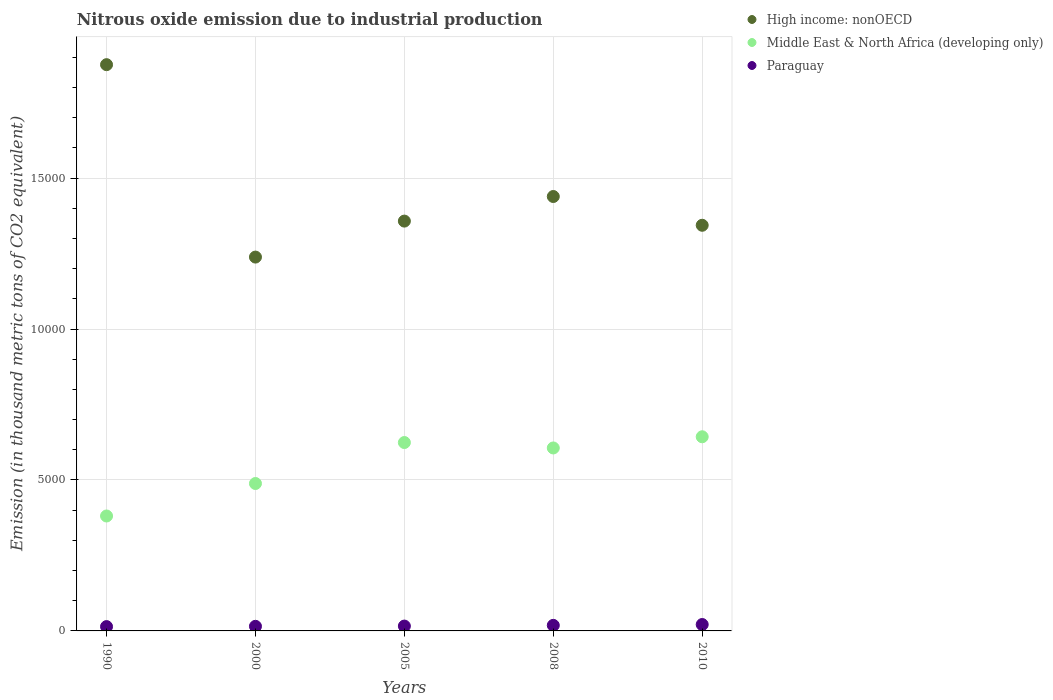How many different coloured dotlines are there?
Your response must be concise. 3. What is the amount of nitrous oxide emitted in Paraguay in 1990?
Your response must be concise. 143. Across all years, what is the maximum amount of nitrous oxide emitted in Paraguay?
Your response must be concise. 211.9. Across all years, what is the minimum amount of nitrous oxide emitted in High income: nonOECD?
Offer a terse response. 1.24e+04. In which year was the amount of nitrous oxide emitted in Middle East & North Africa (developing only) minimum?
Your response must be concise. 1990. What is the total amount of nitrous oxide emitted in High income: nonOECD in the graph?
Your answer should be compact. 7.25e+04. What is the difference between the amount of nitrous oxide emitted in Middle East & North Africa (developing only) in 1990 and that in 2005?
Provide a succinct answer. -2433. What is the difference between the amount of nitrous oxide emitted in High income: nonOECD in 2005 and the amount of nitrous oxide emitted in Middle East & North Africa (developing only) in 2010?
Your answer should be very brief. 7143.7. What is the average amount of nitrous oxide emitted in Paraguay per year?
Make the answer very short. 170.42. In the year 2008, what is the difference between the amount of nitrous oxide emitted in Middle East & North Africa (developing only) and amount of nitrous oxide emitted in Paraguay?
Provide a short and direct response. 5876.1. In how many years, is the amount of nitrous oxide emitted in Middle East & North Africa (developing only) greater than 9000 thousand metric tons?
Your answer should be compact. 0. What is the ratio of the amount of nitrous oxide emitted in High income: nonOECD in 1990 to that in 2008?
Make the answer very short. 1.3. What is the difference between the highest and the second highest amount of nitrous oxide emitted in High income: nonOECD?
Provide a short and direct response. 4366.8. What is the difference between the highest and the lowest amount of nitrous oxide emitted in Paraguay?
Offer a terse response. 68.9. Is it the case that in every year, the sum of the amount of nitrous oxide emitted in Middle East & North Africa (developing only) and amount of nitrous oxide emitted in Paraguay  is greater than the amount of nitrous oxide emitted in High income: nonOECD?
Provide a succinct answer. No. Does the amount of nitrous oxide emitted in Paraguay monotonically increase over the years?
Your answer should be compact. Yes. How many dotlines are there?
Make the answer very short. 3. How many years are there in the graph?
Your answer should be very brief. 5. What is the difference between two consecutive major ticks on the Y-axis?
Provide a short and direct response. 5000. Are the values on the major ticks of Y-axis written in scientific E-notation?
Your response must be concise. No. Does the graph contain grids?
Offer a very short reply. Yes. Where does the legend appear in the graph?
Provide a short and direct response. Top right. What is the title of the graph?
Provide a succinct answer. Nitrous oxide emission due to industrial production. Does "Panama" appear as one of the legend labels in the graph?
Ensure brevity in your answer.  No. What is the label or title of the X-axis?
Your answer should be very brief. Years. What is the label or title of the Y-axis?
Keep it short and to the point. Emission (in thousand metric tons of CO2 equivalent). What is the Emission (in thousand metric tons of CO2 equivalent) of High income: nonOECD in 1990?
Provide a succinct answer. 1.88e+04. What is the Emission (in thousand metric tons of CO2 equivalent) of Middle East & North Africa (developing only) in 1990?
Provide a short and direct response. 3806.6. What is the Emission (in thousand metric tons of CO2 equivalent) of Paraguay in 1990?
Keep it short and to the point. 143. What is the Emission (in thousand metric tons of CO2 equivalent) of High income: nonOECD in 2000?
Provide a succinct answer. 1.24e+04. What is the Emission (in thousand metric tons of CO2 equivalent) in Middle East & North Africa (developing only) in 2000?
Offer a very short reply. 4882.9. What is the Emission (in thousand metric tons of CO2 equivalent) in Paraguay in 2000?
Offer a very short reply. 152.5. What is the Emission (in thousand metric tons of CO2 equivalent) of High income: nonOECD in 2005?
Make the answer very short. 1.36e+04. What is the Emission (in thousand metric tons of CO2 equivalent) in Middle East & North Africa (developing only) in 2005?
Give a very brief answer. 6239.6. What is the Emission (in thousand metric tons of CO2 equivalent) in Paraguay in 2005?
Provide a succinct answer. 160.6. What is the Emission (in thousand metric tons of CO2 equivalent) in High income: nonOECD in 2008?
Provide a short and direct response. 1.44e+04. What is the Emission (in thousand metric tons of CO2 equivalent) in Middle East & North Africa (developing only) in 2008?
Your answer should be very brief. 6060.2. What is the Emission (in thousand metric tons of CO2 equivalent) in Paraguay in 2008?
Your response must be concise. 184.1. What is the Emission (in thousand metric tons of CO2 equivalent) of High income: nonOECD in 2010?
Ensure brevity in your answer.  1.34e+04. What is the Emission (in thousand metric tons of CO2 equivalent) in Middle East & North Africa (developing only) in 2010?
Provide a short and direct response. 6430.5. What is the Emission (in thousand metric tons of CO2 equivalent) of Paraguay in 2010?
Provide a short and direct response. 211.9. Across all years, what is the maximum Emission (in thousand metric tons of CO2 equivalent) of High income: nonOECD?
Your answer should be compact. 1.88e+04. Across all years, what is the maximum Emission (in thousand metric tons of CO2 equivalent) in Middle East & North Africa (developing only)?
Offer a terse response. 6430.5. Across all years, what is the maximum Emission (in thousand metric tons of CO2 equivalent) in Paraguay?
Ensure brevity in your answer.  211.9. Across all years, what is the minimum Emission (in thousand metric tons of CO2 equivalent) of High income: nonOECD?
Your answer should be very brief. 1.24e+04. Across all years, what is the minimum Emission (in thousand metric tons of CO2 equivalent) of Middle East & North Africa (developing only)?
Your answer should be very brief. 3806.6. Across all years, what is the minimum Emission (in thousand metric tons of CO2 equivalent) in Paraguay?
Your response must be concise. 143. What is the total Emission (in thousand metric tons of CO2 equivalent) of High income: nonOECD in the graph?
Ensure brevity in your answer.  7.25e+04. What is the total Emission (in thousand metric tons of CO2 equivalent) in Middle East & North Africa (developing only) in the graph?
Give a very brief answer. 2.74e+04. What is the total Emission (in thousand metric tons of CO2 equivalent) of Paraguay in the graph?
Your answer should be very brief. 852.1. What is the difference between the Emission (in thousand metric tons of CO2 equivalent) of High income: nonOECD in 1990 and that in 2000?
Provide a short and direct response. 6373.1. What is the difference between the Emission (in thousand metric tons of CO2 equivalent) in Middle East & North Africa (developing only) in 1990 and that in 2000?
Keep it short and to the point. -1076.3. What is the difference between the Emission (in thousand metric tons of CO2 equivalent) of Paraguay in 1990 and that in 2000?
Provide a short and direct response. -9.5. What is the difference between the Emission (in thousand metric tons of CO2 equivalent) in High income: nonOECD in 1990 and that in 2005?
Ensure brevity in your answer.  5181.3. What is the difference between the Emission (in thousand metric tons of CO2 equivalent) in Middle East & North Africa (developing only) in 1990 and that in 2005?
Your answer should be compact. -2433. What is the difference between the Emission (in thousand metric tons of CO2 equivalent) of Paraguay in 1990 and that in 2005?
Offer a terse response. -17.6. What is the difference between the Emission (in thousand metric tons of CO2 equivalent) in High income: nonOECD in 1990 and that in 2008?
Offer a very short reply. 4366.8. What is the difference between the Emission (in thousand metric tons of CO2 equivalent) of Middle East & North Africa (developing only) in 1990 and that in 2008?
Your answer should be very brief. -2253.6. What is the difference between the Emission (in thousand metric tons of CO2 equivalent) of Paraguay in 1990 and that in 2008?
Your answer should be very brief. -41.1. What is the difference between the Emission (in thousand metric tons of CO2 equivalent) in High income: nonOECD in 1990 and that in 2010?
Make the answer very short. 5319.5. What is the difference between the Emission (in thousand metric tons of CO2 equivalent) in Middle East & North Africa (developing only) in 1990 and that in 2010?
Keep it short and to the point. -2623.9. What is the difference between the Emission (in thousand metric tons of CO2 equivalent) of Paraguay in 1990 and that in 2010?
Make the answer very short. -68.9. What is the difference between the Emission (in thousand metric tons of CO2 equivalent) in High income: nonOECD in 2000 and that in 2005?
Your answer should be compact. -1191.8. What is the difference between the Emission (in thousand metric tons of CO2 equivalent) in Middle East & North Africa (developing only) in 2000 and that in 2005?
Give a very brief answer. -1356.7. What is the difference between the Emission (in thousand metric tons of CO2 equivalent) in High income: nonOECD in 2000 and that in 2008?
Ensure brevity in your answer.  -2006.3. What is the difference between the Emission (in thousand metric tons of CO2 equivalent) in Middle East & North Africa (developing only) in 2000 and that in 2008?
Offer a terse response. -1177.3. What is the difference between the Emission (in thousand metric tons of CO2 equivalent) of Paraguay in 2000 and that in 2008?
Provide a succinct answer. -31.6. What is the difference between the Emission (in thousand metric tons of CO2 equivalent) in High income: nonOECD in 2000 and that in 2010?
Give a very brief answer. -1053.6. What is the difference between the Emission (in thousand metric tons of CO2 equivalent) in Middle East & North Africa (developing only) in 2000 and that in 2010?
Ensure brevity in your answer.  -1547.6. What is the difference between the Emission (in thousand metric tons of CO2 equivalent) of Paraguay in 2000 and that in 2010?
Offer a very short reply. -59.4. What is the difference between the Emission (in thousand metric tons of CO2 equivalent) of High income: nonOECD in 2005 and that in 2008?
Your answer should be compact. -814.5. What is the difference between the Emission (in thousand metric tons of CO2 equivalent) of Middle East & North Africa (developing only) in 2005 and that in 2008?
Give a very brief answer. 179.4. What is the difference between the Emission (in thousand metric tons of CO2 equivalent) of Paraguay in 2005 and that in 2008?
Offer a very short reply. -23.5. What is the difference between the Emission (in thousand metric tons of CO2 equivalent) in High income: nonOECD in 2005 and that in 2010?
Your response must be concise. 138.2. What is the difference between the Emission (in thousand metric tons of CO2 equivalent) of Middle East & North Africa (developing only) in 2005 and that in 2010?
Offer a very short reply. -190.9. What is the difference between the Emission (in thousand metric tons of CO2 equivalent) of Paraguay in 2005 and that in 2010?
Make the answer very short. -51.3. What is the difference between the Emission (in thousand metric tons of CO2 equivalent) of High income: nonOECD in 2008 and that in 2010?
Your answer should be compact. 952.7. What is the difference between the Emission (in thousand metric tons of CO2 equivalent) of Middle East & North Africa (developing only) in 2008 and that in 2010?
Make the answer very short. -370.3. What is the difference between the Emission (in thousand metric tons of CO2 equivalent) in Paraguay in 2008 and that in 2010?
Make the answer very short. -27.8. What is the difference between the Emission (in thousand metric tons of CO2 equivalent) in High income: nonOECD in 1990 and the Emission (in thousand metric tons of CO2 equivalent) in Middle East & North Africa (developing only) in 2000?
Ensure brevity in your answer.  1.39e+04. What is the difference between the Emission (in thousand metric tons of CO2 equivalent) of High income: nonOECD in 1990 and the Emission (in thousand metric tons of CO2 equivalent) of Paraguay in 2000?
Ensure brevity in your answer.  1.86e+04. What is the difference between the Emission (in thousand metric tons of CO2 equivalent) of Middle East & North Africa (developing only) in 1990 and the Emission (in thousand metric tons of CO2 equivalent) of Paraguay in 2000?
Keep it short and to the point. 3654.1. What is the difference between the Emission (in thousand metric tons of CO2 equivalent) in High income: nonOECD in 1990 and the Emission (in thousand metric tons of CO2 equivalent) in Middle East & North Africa (developing only) in 2005?
Your response must be concise. 1.25e+04. What is the difference between the Emission (in thousand metric tons of CO2 equivalent) in High income: nonOECD in 1990 and the Emission (in thousand metric tons of CO2 equivalent) in Paraguay in 2005?
Keep it short and to the point. 1.86e+04. What is the difference between the Emission (in thousand metric tons of CO2 equivalent) in Middle East & North Africa (developing only) in 1990 and the Emission (in thousand metric tons of CO2 equivalent) in Paraguay in 2005?
Keep it short and to the point. 3646. What is the difference between the Emission (in thousand metric tons of CO2 equivalent) in High income: nonOECD in 1990 and the Emission (in thousand metric tons of CO2 equivalent) in Middle East & North Africa (developing only) in 2008?
Offer a terse response. 1.27e+04. What is the difference between the Emission (in thousand metric tons of CO2 equivalent) in High income: nonOECD in 1990 and the Emission (in thousand metric tons of CO2 equivalent) in Paraguay in 2008?
Give a very brief answer. 1.86e+04. What is the difference between the Emission (in thousand metric tons of CO2 equivalent) of Middle East & North Africa (developing only) in 1990 and the Emission (in thousand metric tons of CO2 equivalent) of Paraguay in 2008?
Your answer should be compact. 3622.5. What is the difference between the Emission (in thousand metric tons of CO2 equivalent) in High income: nonOECD in 1990 and the Emission (in thousand metric tons of CO2 equivalent) in Middle East & North Africa (developing only) in 2010?
Your response must be concise. 1.23e+04. What is the difference between the Emission (in thousand metric tons of CO2 equivalent) in High income: nonOECD in 1990 and the Emission (in thousand metric tons of CO2 equivalent) in Paraguay in 2010?
Keep it short and to the point. 1.85e+04. What is the difference between the Emission (in thousand metric tons of CO2 equivalent) of Middle East & North Africa (developing only) in 1990 and the Emission (in thousand metric tons of CO2 equivalent) of Paraguay in 2010?
Ensure brevity in your answer.  3594.7. What is the difference between the Emission (in thousand metric tons of CO2 equivalent) in High income: nonOECD in 2000 and the Emission (in thousand metric tons of CO2 equivalent) in Middle East & North Africa (developing only) in 2005?
Provide a short and direct response. 6142.8. What is the difference between the Emission (in thousand metric tons of CO2 equivalent) of High income: nonOECD in 2000 and the Emission (in thousand metric tons of CO2 equivalent) of Paraguay in 2005?
Your response must be concise. 1.22e+04. What is the difference between the Emission (in thousand metric tons of CO2 equivalent) in Middle East & North Africa (developing only) in 2000 and the Emission (in thousand metric tons of CO2 equivalent) in Paraguay in 2005?
Provide a succinct answer. 4722.3. What is the difference between the Emission (in thousand metric tons of CO2 equivalent) of High income: nonOECD in 2000 and the Emission (in thousand metric tons of CO2 equivalent) of Middle East & North Africa (developing only) in 2008?
Provide a short and direct response. 6322.2. What is the difference between the Emission (in thousand metric tons of CO2 equivalent) of High income: nonOECD in 2000 and the Emission (in thousand metric tons of CO2 equivalent) of Paraguay in 2008?
Make the answer very short. 1.22e+04. What is the difference between the Emission (in thousand metric tons of CO2 equivalent) in Middle East & North Africa (developing only) in 2000 and the Emission (in thousand metric tons of CO2 equivalent) in Paraguay in 2008?
Keep it short and to the point. 4698.8. What is the difference between the Emission (in thousand metric tons of CO2 equivalent) of High income: nonOECD in 2000 and the Emission (in thousand metric tons of CO2 equivalent) of Middle East & North Africa (developing only) in 2010?
Provide a succinct answer. 5951.9. What is the difference between the Emission (in thousand metric tons of CO2 equivalent) in High income: nonOECD in 2000 and the Emission (in thousand metric tons of CO2 equivalent) in Paraguay in 2010?
Make the answer very short. 1.22e+04. What is the difference between the Emission (in thousand metric tons of CO2 equivalent) in Middle East & North Africa (developing only) in 2000 and the Emission (in thousand metric tons of CO2 equivalent) in Paraguay in 2010?
Give a very brief answer. 4671. What is the difference between the Emission (in thousand metric tons of CO2 equivalent) of High income: nonOECD in 2005 and the Emission (in thousand metric tons of CO2 equivalent) of Middle East & North Africa (developing only) in 2008?
Make the answer very short. 7514. What is the difference between the Emission (in thousand metric tons of CO2 equivalent) of High income: nonOECD in 2005 and the Emission (in thousand metric tons of CO2 equivalent) of Paraguay in 2008?
Your response must be concise. 1.34e+04. What is the difference between the Emission (in thousand metric tons of CO2 equivalent) of Middle East & North Africa (developing only) in 2005 and the Emission (in thousand metric tons of CO2 equivalent) of Paraguay in 2008?
Offer a terse response. 6055.5. What is the difference between the Emission (in thousand metric tons of CO2 equivalent) in High income: nonOECD in 2005 and the Emission (in thousand metric tons of CO2 equivalent) in Middle East & North Africa (developing only) in 2010?
Your answer should be very brief. 7143.7. What is the difference between the Emission (in thousand metric tons of CO2 equivalent) in High income: nonOECD in 2005 and the Emission (in thousand metric tons of CO2 equivalent) in Paraguay in 2010?
Ensure brevity in your answer.  1.34e+04. What is the difference between the Emission (in thousand metric tons of CO2 equivalent) of Middle East & North Africa (developing only) in 2005 and the Emission (in thousand metric tons of CO2 equivalent) of Paraguay in 2010?
Make the answer very short. 6027.7. What is the difference between the Emission (in thousand metric tons of CO2 equivalent) of High income: nonOECD in 2008 and the Emission (in thousand metric tons of CO2 equivalent) of Middle East & North Africa (developing only) in 2010?
Your response must be concise. 7958.2. What is the difference between the Emission (in thousand metric tons of CO2 equivalent) of High income: nonOECD in 2008 and the Emission (in thousand metric tons of CO2 equivalent) of Paraguay in 2010?
Ensure brevity in your answer.  1.42e+04. What is the difference between the Emission (in thousand metric tons of CO2 equivalent) in Middle East & North Africa (developing only) in 2008 and the Emission (in thousand metric tons of CO2 equivalent) in Paraguay in 2010?
Your answer should be compact. 5848.3. What is the average Emission (in thousand metric tons of CO2 equivalent) of High income: nonOECD per year?
Give a very brief answer. 1.45e+04. What is the average Emission (in thousand metric tons of CO2 equivalent) of Middle East & North Africa (developing only) per year?
Offer a very short reply. 5483.96. What is the average Emission (in thousand metric tons of CO2 equivalent) of Paraguay per year?
Offer a very short reply. 170.42. In the year 1990, what is the difference between the Emission (in thousand metric tons of CO2 equivalent) of High income: nonOECD and Emission (in thousand metric tons of CO2 equivalent) of Middle East & North Africa (developing only)?
Ensure brevity in your answer.  1.49e+04. In the year 1990, what is the difference between the Emission (in thousand metric tons of CO2 equivalent) of High income: nonOECD and Emission (in thousand metric tons of CO2 equivalent) of Paraguay?
Your answer should be compact. 1.86e+04. In the year 1990, what is the difference between the Emission (in thousand metric tons of CO2 equivalent) in Middle East & North Africa (developing only) and Emission (in thousand metric tons of CO2 equivalent) in Paraguay?
Offer a very short reply. 3663.6. In the year 2000, what is the difference between the Emission (in thousand metric tons of CO2 equivalent) of High income: nonOECD and Emission (in thousand metric tons of CO2 equivalent) of Middle East & North Africa (developing only)?
Your answer should be very brief. 7499.5. In the year 2000, what is the difference between the Emission (in thousand metric tons of CO2 equivalent) of High income: nonOECD and Emission (in thousand metric tons of CO2 equivalent) of Paraguay?
Give a very brief answer. 1.22e+04. In the year 2000, what is the difference between the Emission (in thousand metric tons of CO2 equivalent) of Middle East & North Africa (developing only) and Emission (in thousand metric tons of CO2 equivalent) of Paraguay?
Provide a short and direct response. 4730.4. In the year 2005, what is the difference between the Emission (in thousand metric tons of CO2 equivalent) of High income: nonOECD and Emission (in thousand metric tons of CO2 equivalent) of Middle East & North Africa (developing only)?
Your answer should be compact. 7334.6. In the year 2005, what is the difference between the Emission (in thousand metric tons of CO2 equivalent) of High income: nonOECD and Emission (in thousand metric tons of CO2 equivalent) of Paraguay?
Your response must be concise. 1.34e+04. In the year 2005, what is the difference between the Emission (in thousand metric tons of CO2 equivalent) in Middle East & North Africa (developing only) and Emission (in thousand metric tons of CO2 equivalent) in Paraguay?
Your answer should be very brief. 6079. In the year 2008, what is the difference between the Emission (in thousand metric tons of CO2 equivalent) in High income: nonOECD and Emission (in thousand metric tons of CO2 equivalent) in Middle East & North Africa (developing only)?
Make the answer very short. 8328.5. In the year 2008, what is the difference between the Emission (in thousand metric tons of CO2 equivalent) of High income: nonOECD and Emission (in thousand metric tons of CO2 equivalent) of Paraguay?
Ensure brevity in your answer.  1.42e+04. In the year 2008, what is the difference between the Emission (in thousand metric tons of CO2 equivalent) of Middle East & North Africa (developing only) and Emission (in thousand metric tons of CO2 equivalent) of Paraguay?
Your response must be concise. 5876.1. In the year 2010, what is the difference between the Emission (in thousand metric tons of CO2 equivalent) in High income: nonOECD and Emission (in thousand metric tons of CO2 equivalent) in Middle East & North Africa (developing only)?
Your answer should be compact. 7005.5. In the year 2010, what is the difference between the Emission (in thousand metric tons of CO2 equivalent) of High income: nonOECD and Emission (in thousand metric tons of CO2 equivalent) of Paraguay?
Your answer should be compact. 1.32e+04. In the year 2010, what is the difference between the Emission (in thousand metric tons of CO2 equivalent) of Middle East & North Africa (developing only) and Emission (in thousand metric tons of CO2 equivalent) of Paraguay?
Offer a terse response. 6218.6. What is the ratio of the Emission (in thousand metric tons of CO2 equivalent) of High income: nonOECD in 1990 to that in 2000?
Your response must be concise. 1.51. What is the ratio of the Emission (in thousand metric tons of CO2 equivalent) of Middle East & North Africa (developing only) in 1990 to that in 2000?
Your answer should be very brief. 0.78. What is the ratio of the Emission (in thousand metric tons of CO2 equivalent) in Paraguay in 1990 to that in 2000?
Offer a terse response. 0.94. What is the ratio of the Emission (in thousand metric tons of CO2 equivalent) in High income: nonOECD in 1990 to that in 2005?
Make the answer very short. 1.38. What is the ratio of the Emission (in thousand metric tons of CO2 equivalent) of Middle East & North Africa (developing only) in 1990 to that in 2005?
Provide a succinct answer. 0.61. What is the ratio of the Emission (in thousand metric tons of CO2 equivalent) in Paraguay in 1990 to that in 2005?
Ensure brevity in your answer.  0.89. What is the ratio of the Emission (in thousand metric tons of CO2 equivalent) of High income: nonOECD in 1990 to that in 2008?
Give a very brief answer. 1.3. What is the ratio of the Emission (in thousand metric tons of CO2 equivalent) of Middle East & North Africa (developing only) in 1990 to that in 2008?
Keep it short and to the point. 0.63. What is the ratio of the Emission (in thousand metric tons of CO2 equivalent) of Paraguay in 1990 to that in 2008?
Your response must be concise. 0.78. What is the ratio of the Emission (in thousand metric tons of CO2 equivalent) of High income: nonOECD in 1990 to that in 2010?
Provide a short and direct response. 1.4. What is the ratio of the Emission (in thousand metric tons of CO2 equivalent) of Middle East & North Africa (developing only) in 1990 to that in 2010?
Give a very brief answer. 0.59. What is the ratio of the Emission (in thousand metric tons of CO2 equivalent) of Paraguay in 1990 to that in 2010?
Provide a succinct answer. 0.67. What is the ratio of the Emission (in thousand metric tons of CO2 equivalent) of High income: nonOECD in 2000 to that in 2005?
Provide a succinct answer. 0.91. What is the ratio of the Emission (in thousand metric tons of CO2 equivalent) of Middle East & North Africa (developing only) in 2000 to that in 2005?
Your response must be concise. 0.78. What is the ratio of the Emission (in thousand metric tons of CO2 equivalent) of Paraguay in 2000 to that in 2005?
Provide a succinct answer. 0.95. What is the ratio of the Emission (in thousand metric tons of CO2 equivalent) of High income: nonOECD in 2000 to that in 2008?
Offer a very short reply. 0.86. What is the ratio of the Emission (in thousand metric tons of CO2 equivalent) in Middle East & North Africa (developing only) in 2000 to that in 2008?
Your answer should be compact. 0.81. What is the ratio of the Emission (in thousand metric tons of CO2 equivalent) in Paraguay in 2000 to that in 2008?
Your response must be concise. 0.83. What is the ratio of the Emission (in thousand metric tons of CO2 equivalent) in High income: nonOECD in 2000 to that in 2010?
Offer a very short reply. 0.92. What is the ratio of the Emission (in thousand metric tons of CO2 equivalent) in Middle East & North Africa (developing only) in 2000 to that in 2010?
Offer a very short reply. 0.76. What is the ratio of the Emission (in thousand metric tons of CO2 equivalent) of Paraguay in 2000 to that in 2010?
Make the answer very short. 0.72. What is the ratio of the Emission (in thousand metric tons of CO2 equivalent) of High income: nonOECD in 2005 to that in 2008?
Provide a short and direct response. 0.94. What is the ratio of the Emission (in thousand metric tons of CO2 equivalent) in Middle East & North Africa (developing only) in 2005 to that in 2008?
Your answer should be compact. 1.03. What is the ratio of the Emission (in thousand metric tons of CO2 equivalent) in Paraguay in 2005 to that in 2008?
Keep it short and to the point. 0.87. What is the ratio of the Emission (in thousand metric tons of CO2 equivalent) in High income: nonOECD in 2005 to that in 2010?
Offer a terse response. 1.01. What is the ratio of the Emission (in thousand metric tons of CO2 equivalent) in Middle East & North Africa (developing only) in 2005 to that in 2010?
Offer a very short reply. 0.97. What is the ratio of the Emission (in thousand metric tons of CO2 equivalent) in Paraguay in 2005 to that in 2010?
Your answer should be very brief. 0.76. What is the ratio of the Emission (in thousand metric tons of CO2 equivalent) of High income: nonOECD in 2008 to that in 2010?
Provide a succinct answer. 1.07. What is the ratio of the Emission (in thousand metric tons of CO2 equivalent) of Middle East & North Africa (developing only) in 2008 to that in 2010?
Your response must be concise. 0.94. What is the ratio of the Emission (in thousand metric tons of CO2 equivalent) of Paraguay in 2008 to that in 2010?
Provide a succinct answer. 0.87. What is the difference between the highest and the second highest Emission (in thousand metric tons of CO2 equivalent) in High income: nonOECD?
Offer a very short reply. 4366.8. What is the difference between the highest and the second highest Emission (in thousand metric tons of CO2 equivalent) in Middle East & North Africa (developing only)?
Offer a terse response. 190.9. What is the difference between the highest and the second highest Emission (in thousand metric tons of CO2 equivalent) of Paraguay?
Your answer should be compact. 27.8. What is the difference between the highest and the lowest Emission (in thousand metric tons of CO2 equivalent) in High income: nonOECD?
Keep it short and to the point. 6373.1. What is the difference between the highest and the lowest Emission (in thousand metric tons of CO2 equivalent) of Middle East & North Africa (developing only)?
Offer a very short reply. 2623.9. What is the difference between the highest and the lowest Emission (in thousand metric tons of CO2 equivalent) in Paraguay?
Keep it short and to the point. 68.9. 